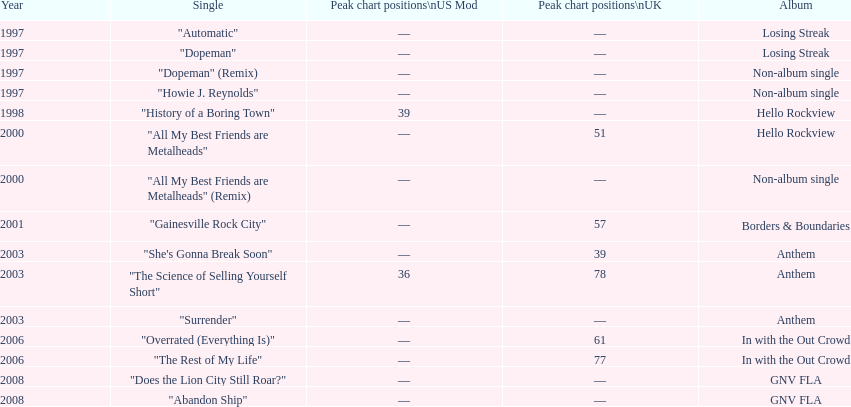What was the next single after "overrated (everything is)"? "The Rest of My Life". 